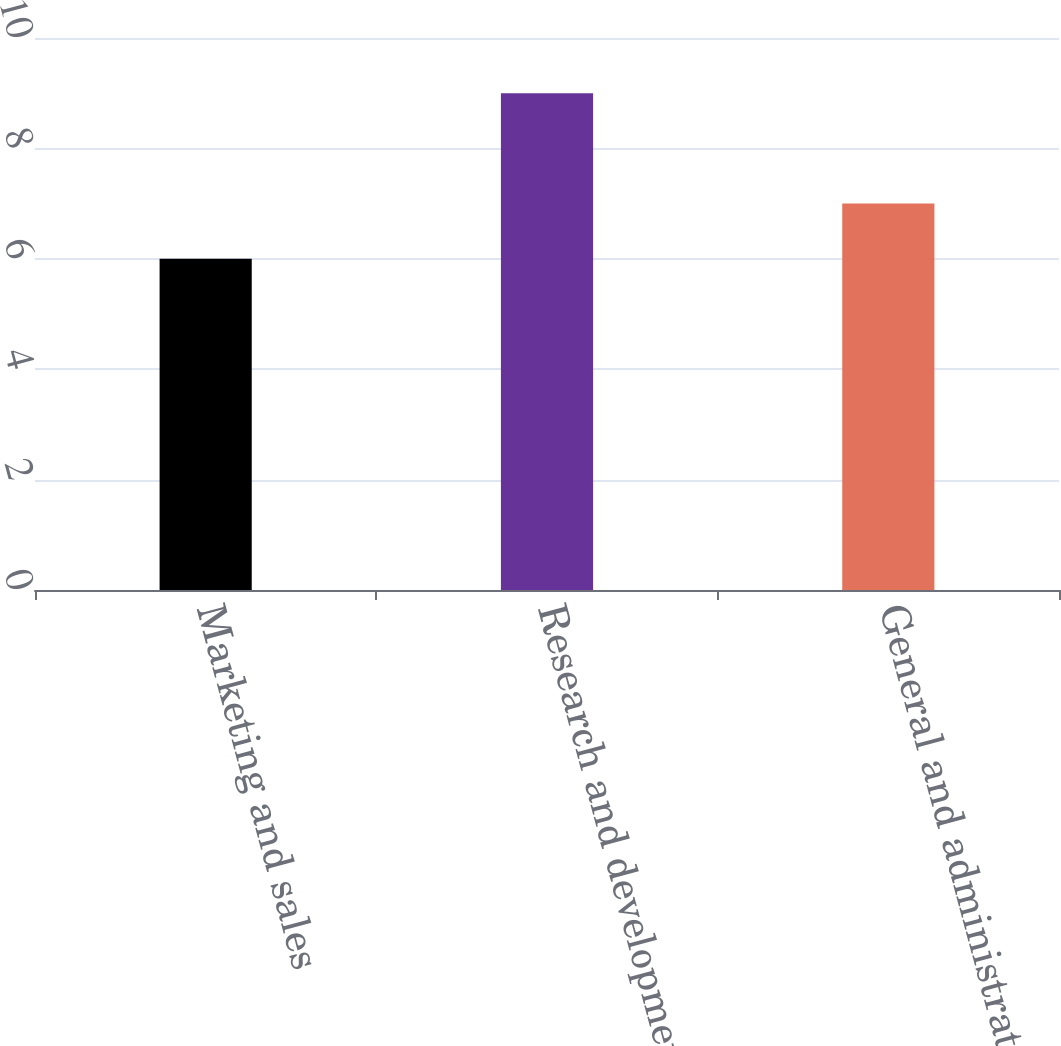<chart> <loc_0><loc_0><loc_500><loc_500><bar_chart><fcel>Marketing and sales<fcel>Research and development<fcel>General and administrative<nl><fcel>6<fcel>9<fcel>7<nl></chart> 